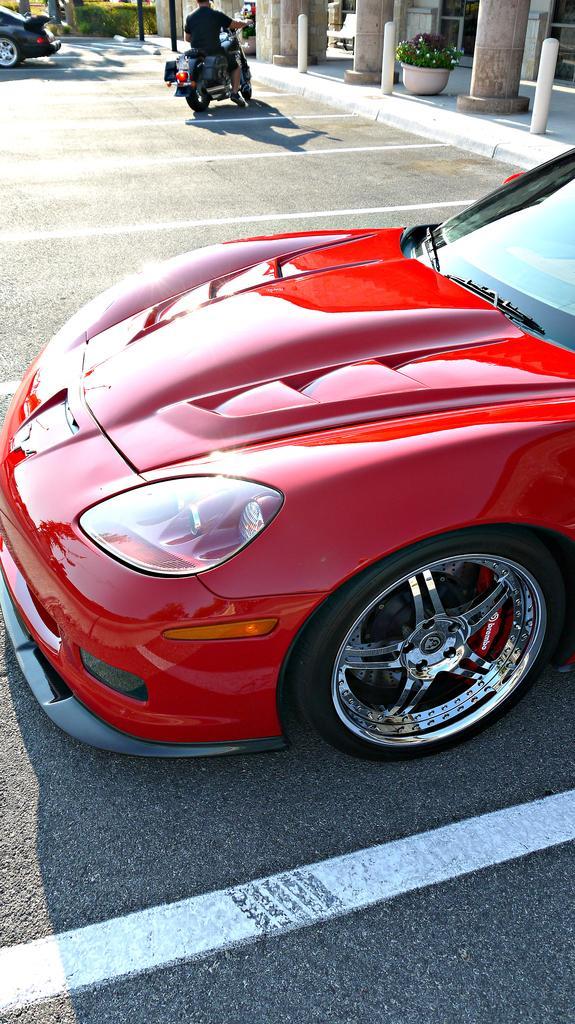How would you summarize this image in a sentence or two? In this image I see red colored car which is on the road and In the background I see pillars, a plant over here and a bike on which there is a man and I see another car which is black in color, which is also on the road. 